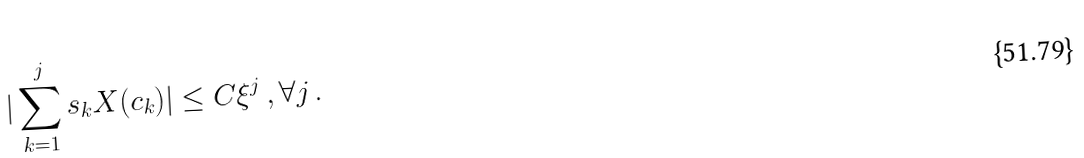<formula> <loc_0><loc_0><loc_500><loc_500>| \sum _ { k = 1 } ^ { j } s _ { k } X ( c _ { k } ) | \leq C \xi ^ { j } \, , \forall j \, .</formula> 